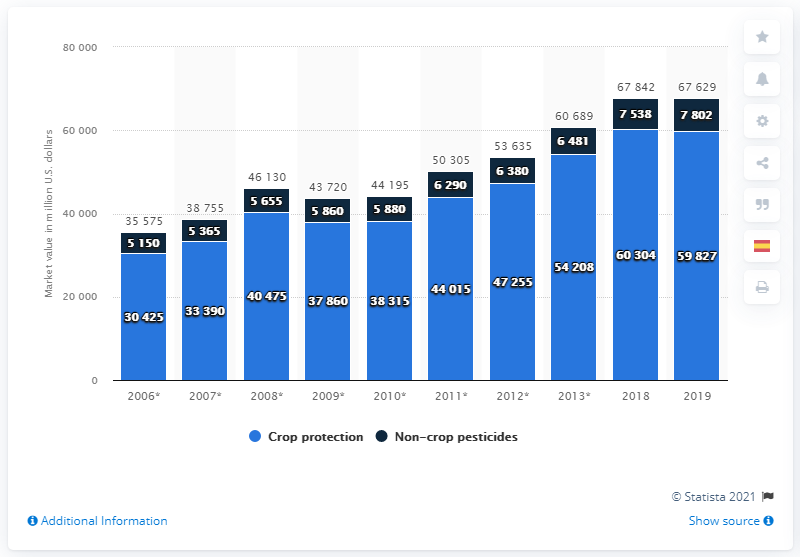Outline some significant characteristics in this image. The global market for crop protection related to agrochemicals in the year 2019 was valued at approximately 59,827. 